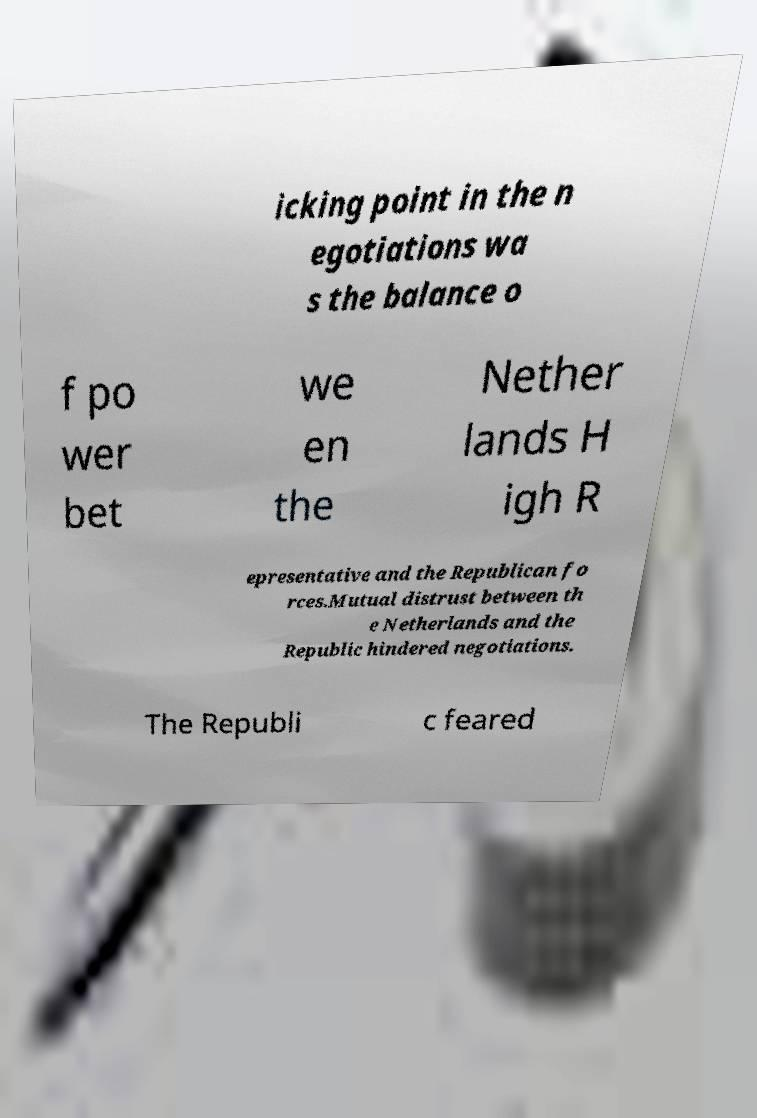For documentation purposes, I need the text within this image transcribed. Could you provide that? icking point in the n egotiations wa s the balance o f po wer bet we en the Nether lands H igh R epresentative and the Republican fo rces.Mutual distrust between th e Netherlands and the Republic hindered negotiations. The Republi c feared 